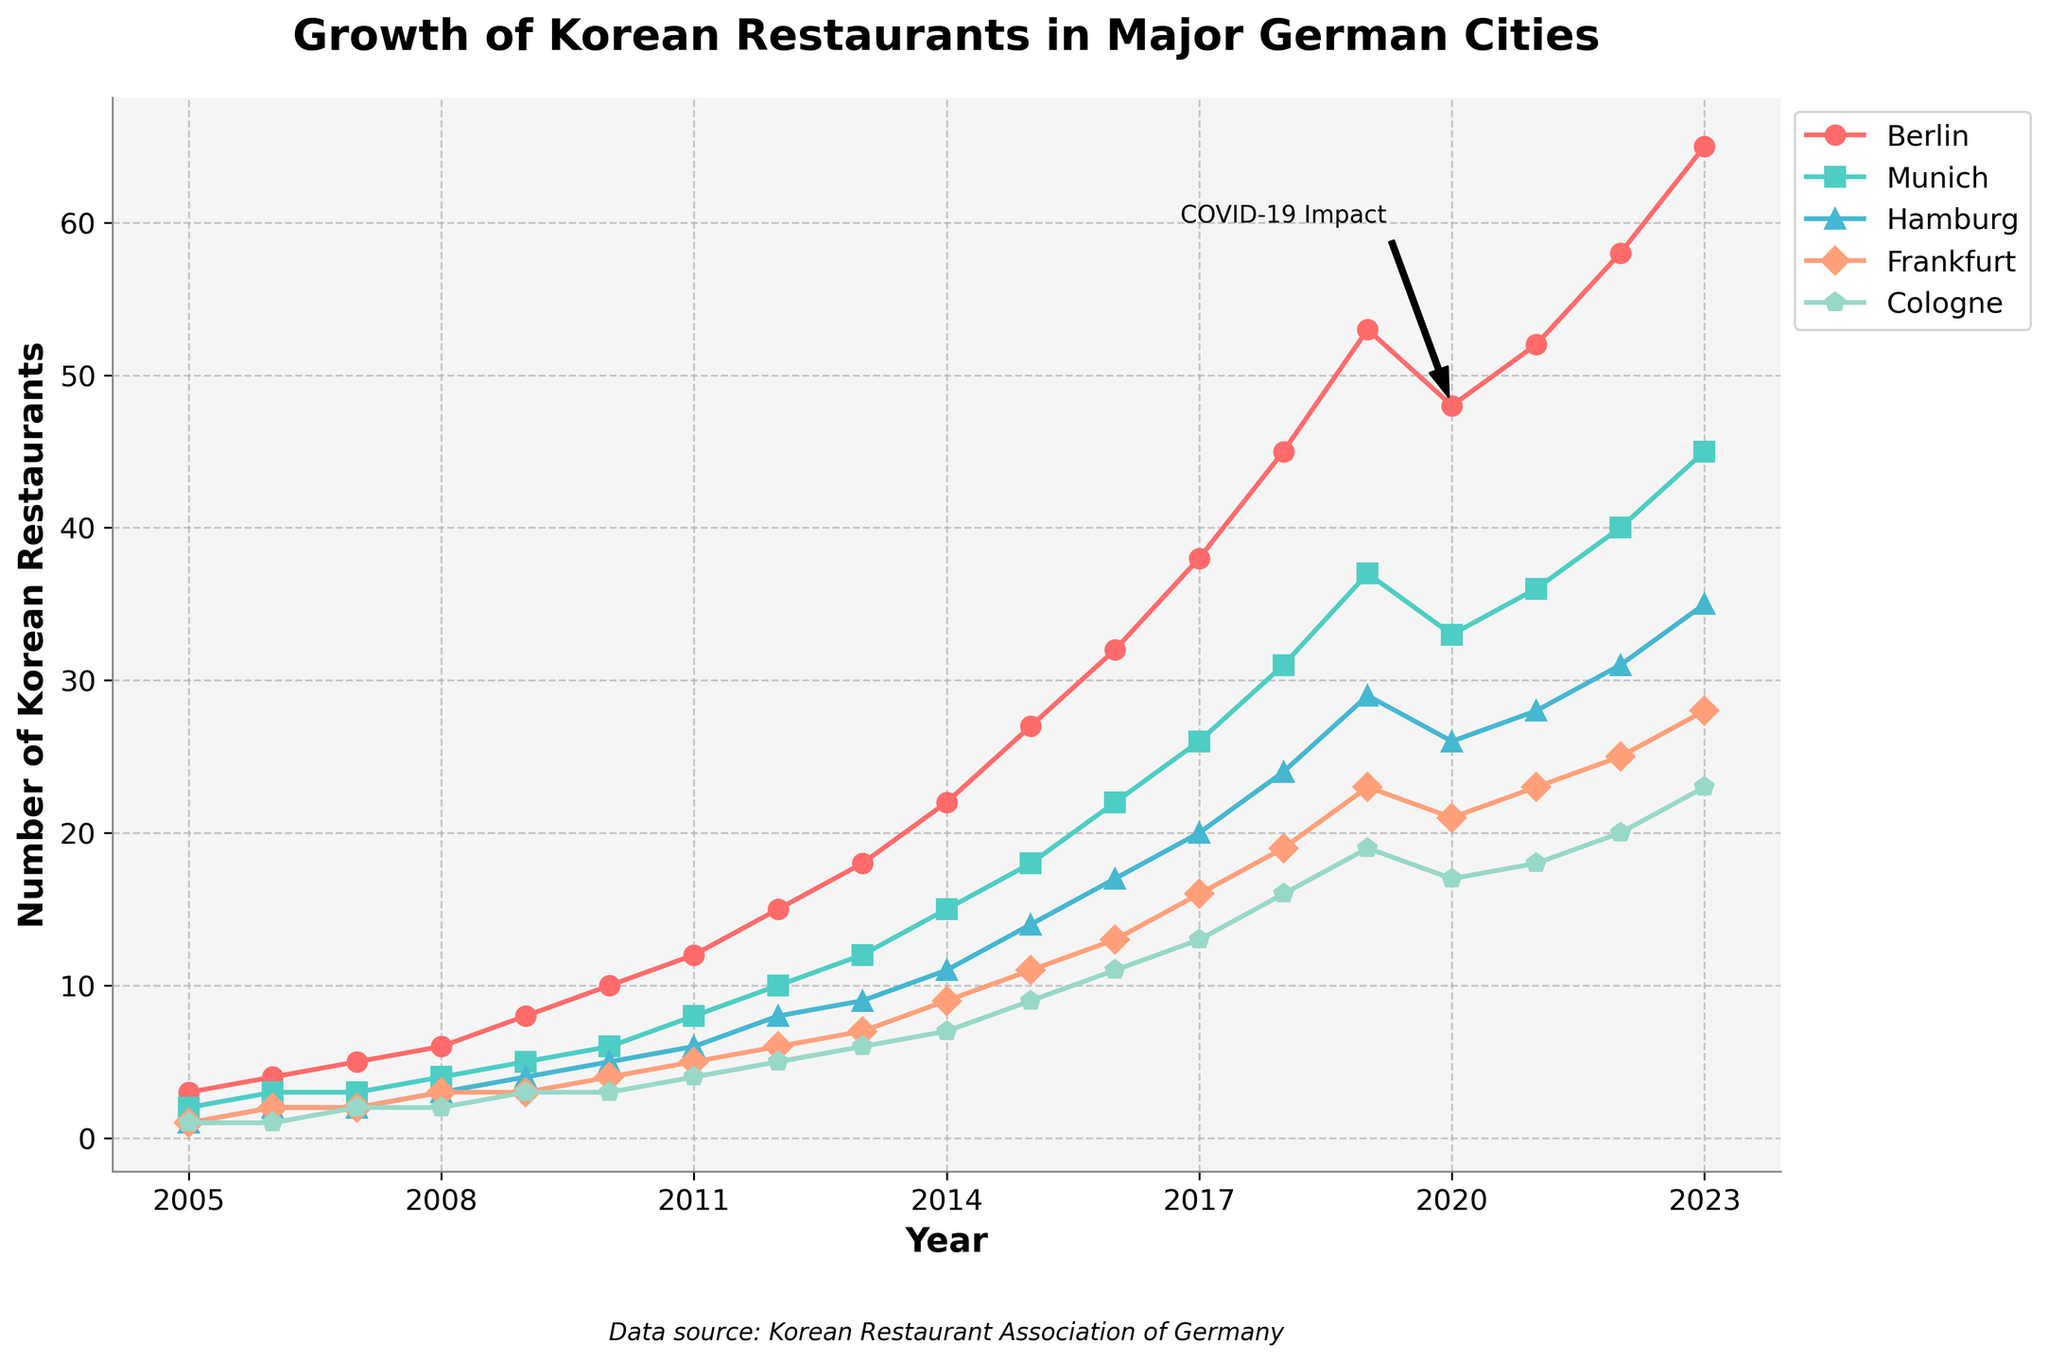What year did Berlin see the highest number of new Korean restaurants opening? To identify the year when Berlin saw the highest number of openings, look at the peak point of the Berlin line. This happens in 2023 with 65 new restaurants.
Answer: 2023 How many new Korean restaurants opened in Cologne between 2010 and 2013? To find the total, add the values for Cologne for the years 2010, 2011, 2012, and 2013: 3 + 4 + 5 + 6 = 18.
Answer: 18 Which city has the smallest increase in the number of new Korean restaurants from 2020 to 2023? To determine this, subtract the 2020 value from the 2023 value for each city and compare the differences. Cologne has the smallest increase, from 17 to 23, which is 6.
Answer: Cologne What is the average number of new Korean restaurants opened annually in Munich between 2005 and 2010? Calculate the average by summing the values for Munich from 2005 to 2010: (2 + 3 + 3 + 4 + 5 + 6) = 23, then divide by 6 (the number of years). So, 23/6 ≈ 3.83.
Answer: 3.83 Which city showed the clearest impact from COVID-19, witnessing a decrease in new restaurant openings in 2020 compared to 2019? To determine which city had a decrease, compare the values between 2019 and 2020. Berlin shows a decrease from 53 to 48, the most significant drop.
Answer: Berlin By how much did the number of new Korean restaurants open in Frankfurt change from 2019 to 2022? Subtract the 2019 value from the 2022 value for Frankfurt: 25 - 23 = 2.
Answer: 2 How many years did it take for Hamburg to increase from 1 to 20 new Korean restaurants opened annually? Identify the years when Hamburg first recorded 1 and then 20 new openings. Hamburg had 1 in 2005 and 20 in 2017, so it took 12 years.
Answer: 12 Which city had the most consistent growth in new Korean restaurants over the years, based on the slope of the lines? By visually inspecting the steepness and consistency of each line, Munich appears to have the most steady, consistent upward trend without abrupt changes.
Answer: Munich In which year did Frankfurt first surpass 10 new Korean restaurant openings annually? Look for the first point where Frankfurt's values exceed 10. This happens in 2015 with 11 new openings.
Answer: 2015 What is the total number of new Korean restaurants that opened in Hamburg from 2018 to 2023? Sum the values for Hamburg from 2018 to 2023: 24 + 29 + 26 + 28 + 31 + 35 = 173.
Answer: 173 